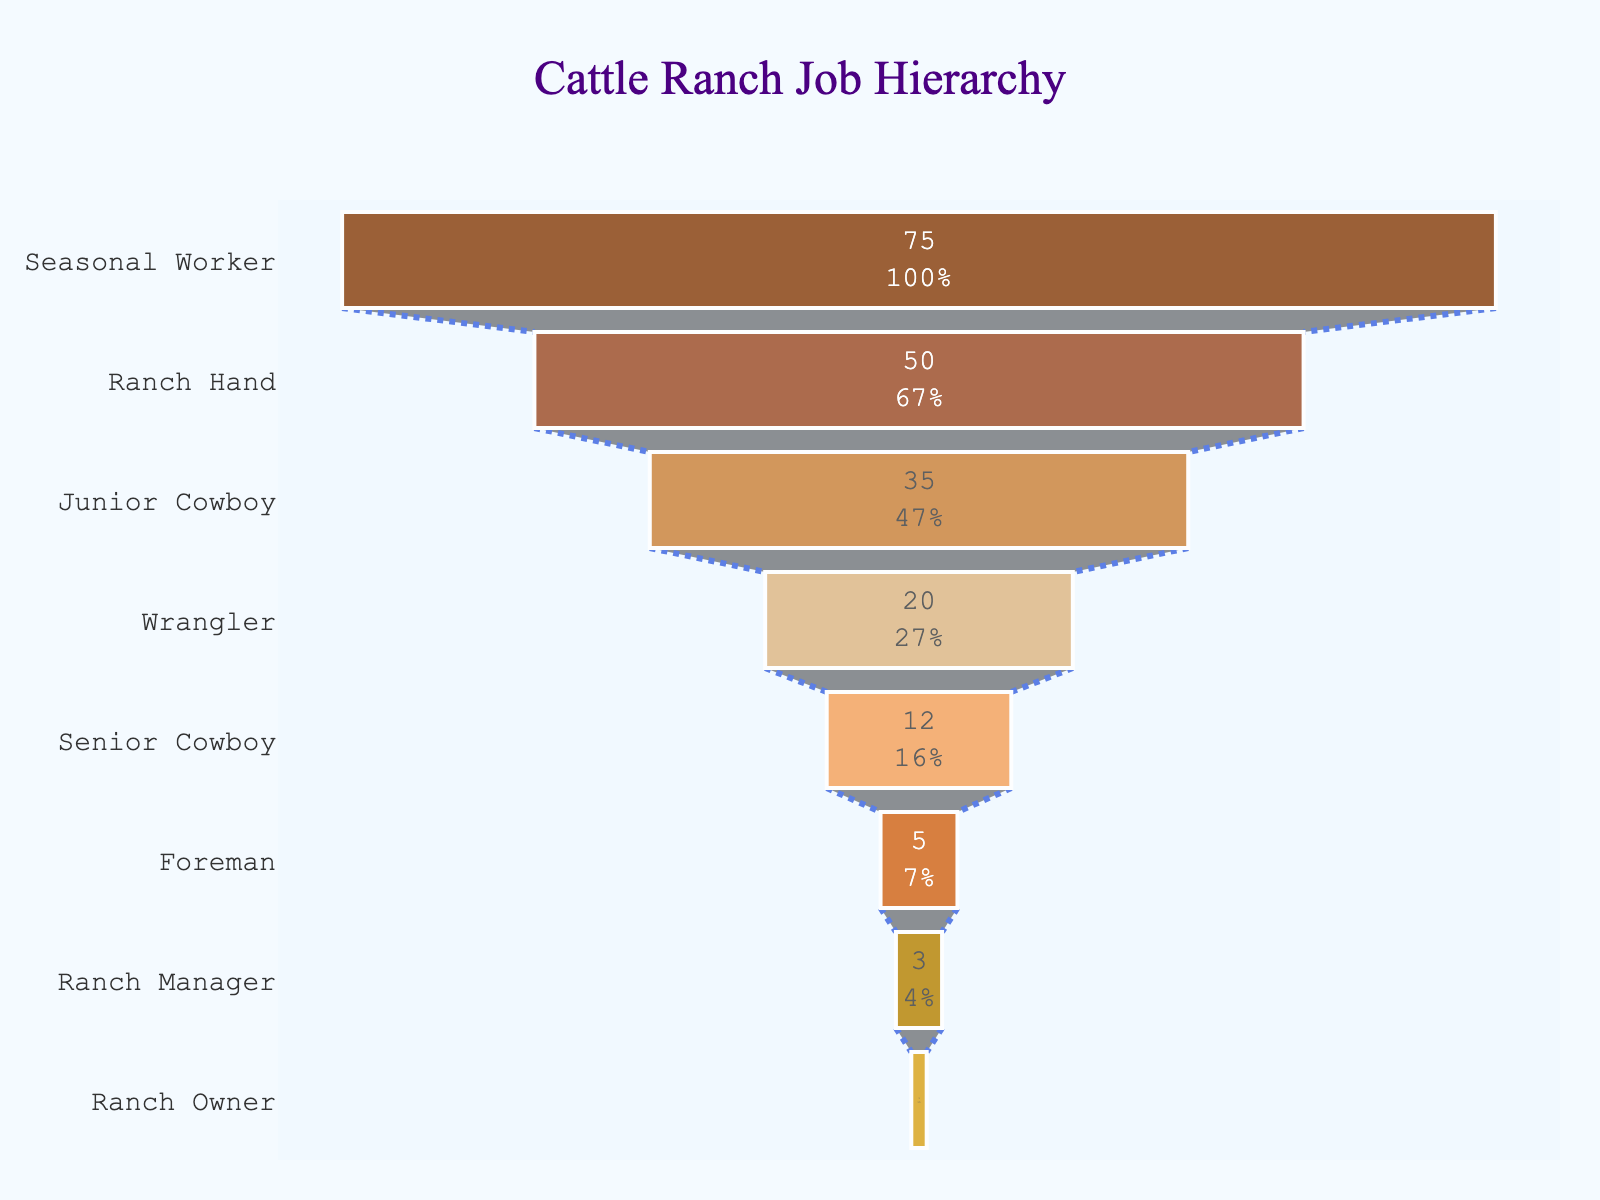what is the title of the chart? The title is located at the top of the chart and gives an overview of what the chart is representing. By reading the text centered at the top, you can find the title.
Answer: Cattle Ranch Job Hierarchy What is the role with the highest number of workers? Look at the funnel chart and identify the segment that is the widest, which indicates the highest number of workers. The label corresponding to this segment reveals the role.
Answer: Seasonal Worker How many Ranch Managers are there compared to Ranch Owners? Locate the segments for "Ranch Manager" and "Ranch Owner." Read the numbers associated with each segment and compare them.
Answer: There are 3 Ranch Managers and 1 Ranch Owner What percentage of the total workforce do the Wrangler and Junior Cowboy roles together comprise? Find the segments for "Wrangler" and "Junior Cowboy." Sum their numbers and then divide by the total number of all positions. Multiply by 100 to get the percentage.
Answer: The Wrangler and Junior Cowboy roles together comprise 67.5% What role has a similar number of workers as Foreman but slightly more? Find the segment labeled "Foreman" and identify the number. Then find the segment just above it in hierarchy and check the number to see it has slightly more workers.
Answer: Senior Cowboy How does the number of Ranch Hands compare to the number of Ranch Managers and Foremen combined? Find the segments for "Ranch Hand," "Ranch Manager," and "Foreman." Add the numbers for "Ranch Manager" and "Foreman," then compare the sum to the number for "Ranch Hand."
Answer: Ranch Hands have more than Ranch Managers and Foremen combined What is the color of the segment representing the Ranch Owner? Observe the hue used to color the segment labeled "Ranch Owner."
Answer: Dark Brown How many roles have fewer than 10 workers each? Identify the segments with values less than 10 and count them.
Answer: Two roles Which role follows immediately after Wrangler in the hierarchy? Observe the labels of the segments and find the one that is directly above Wrangler.
Answer: Senior Cowboy 